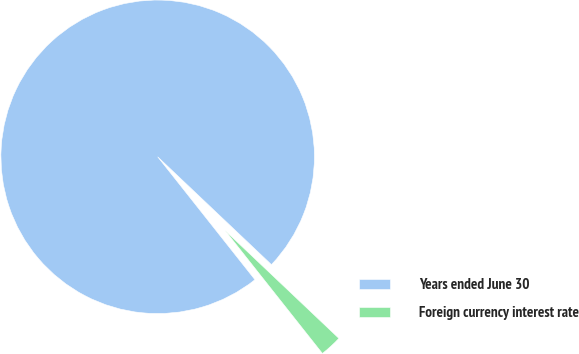Convert chart. <chart><loc_0><loc_0><loc_500><loc_500><pie_chart><fcel>Years ended June 30<fcel>Foreign currency interest rate<nl><fcel>97.73%<fcel>2.27%<nl></chart> 